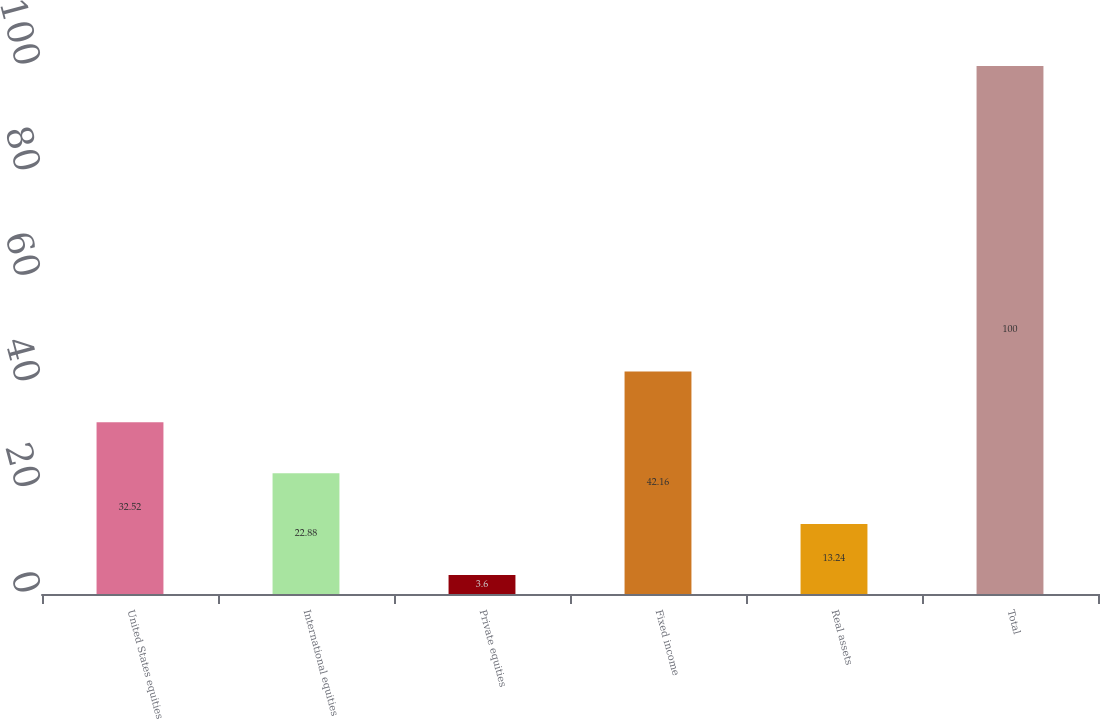<chart> <loc_0><loc_0><loc_500><loc_500><bar_chart><fcel>United States equities<fcel>International equities<fcel>Private equities<fcel>Fixed income<fcel>Real assets<fcel>Total<nl><fcel>32.52<fcel>22.88<fcel>3.6<fcel>42.16<fcel>13.24<fcel>100<nl></chart> 